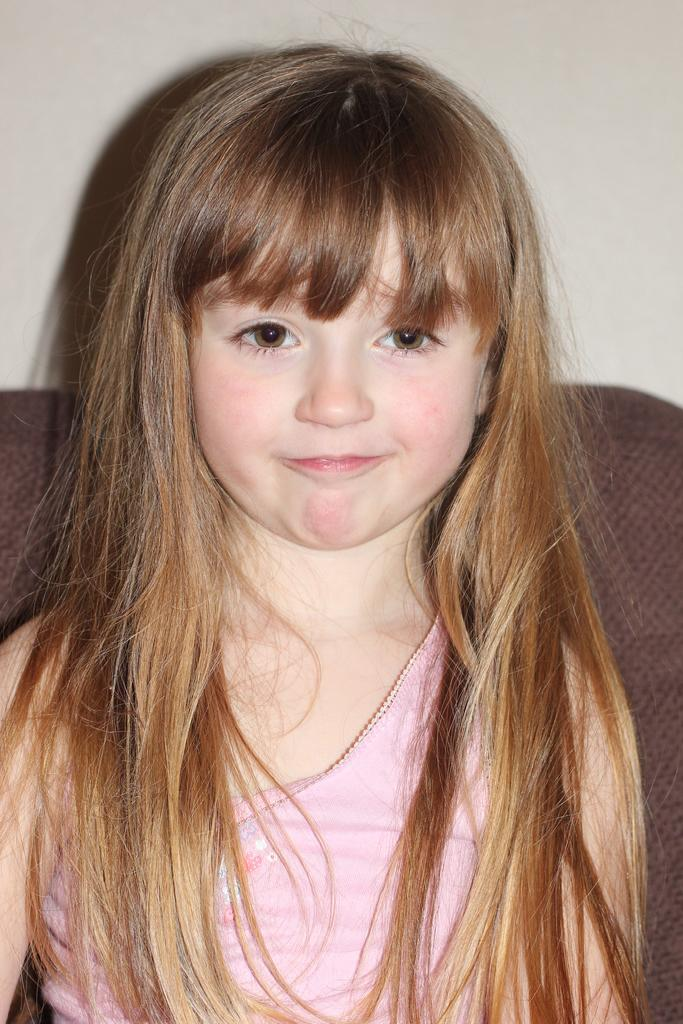What is the main subject of the image? The main subject of the image is a girl. What is the girl wearing in the image? The girl is wearing a pink dress. What piece of furniture is the girl sitting on in the image? The girl is sitting on a sofa. What type of dinner is the girl preparing on the hook in the image? There is no hook or dinner preparation visible in the image; it features a girl sitting on a sofa while wearing a pink dress. 